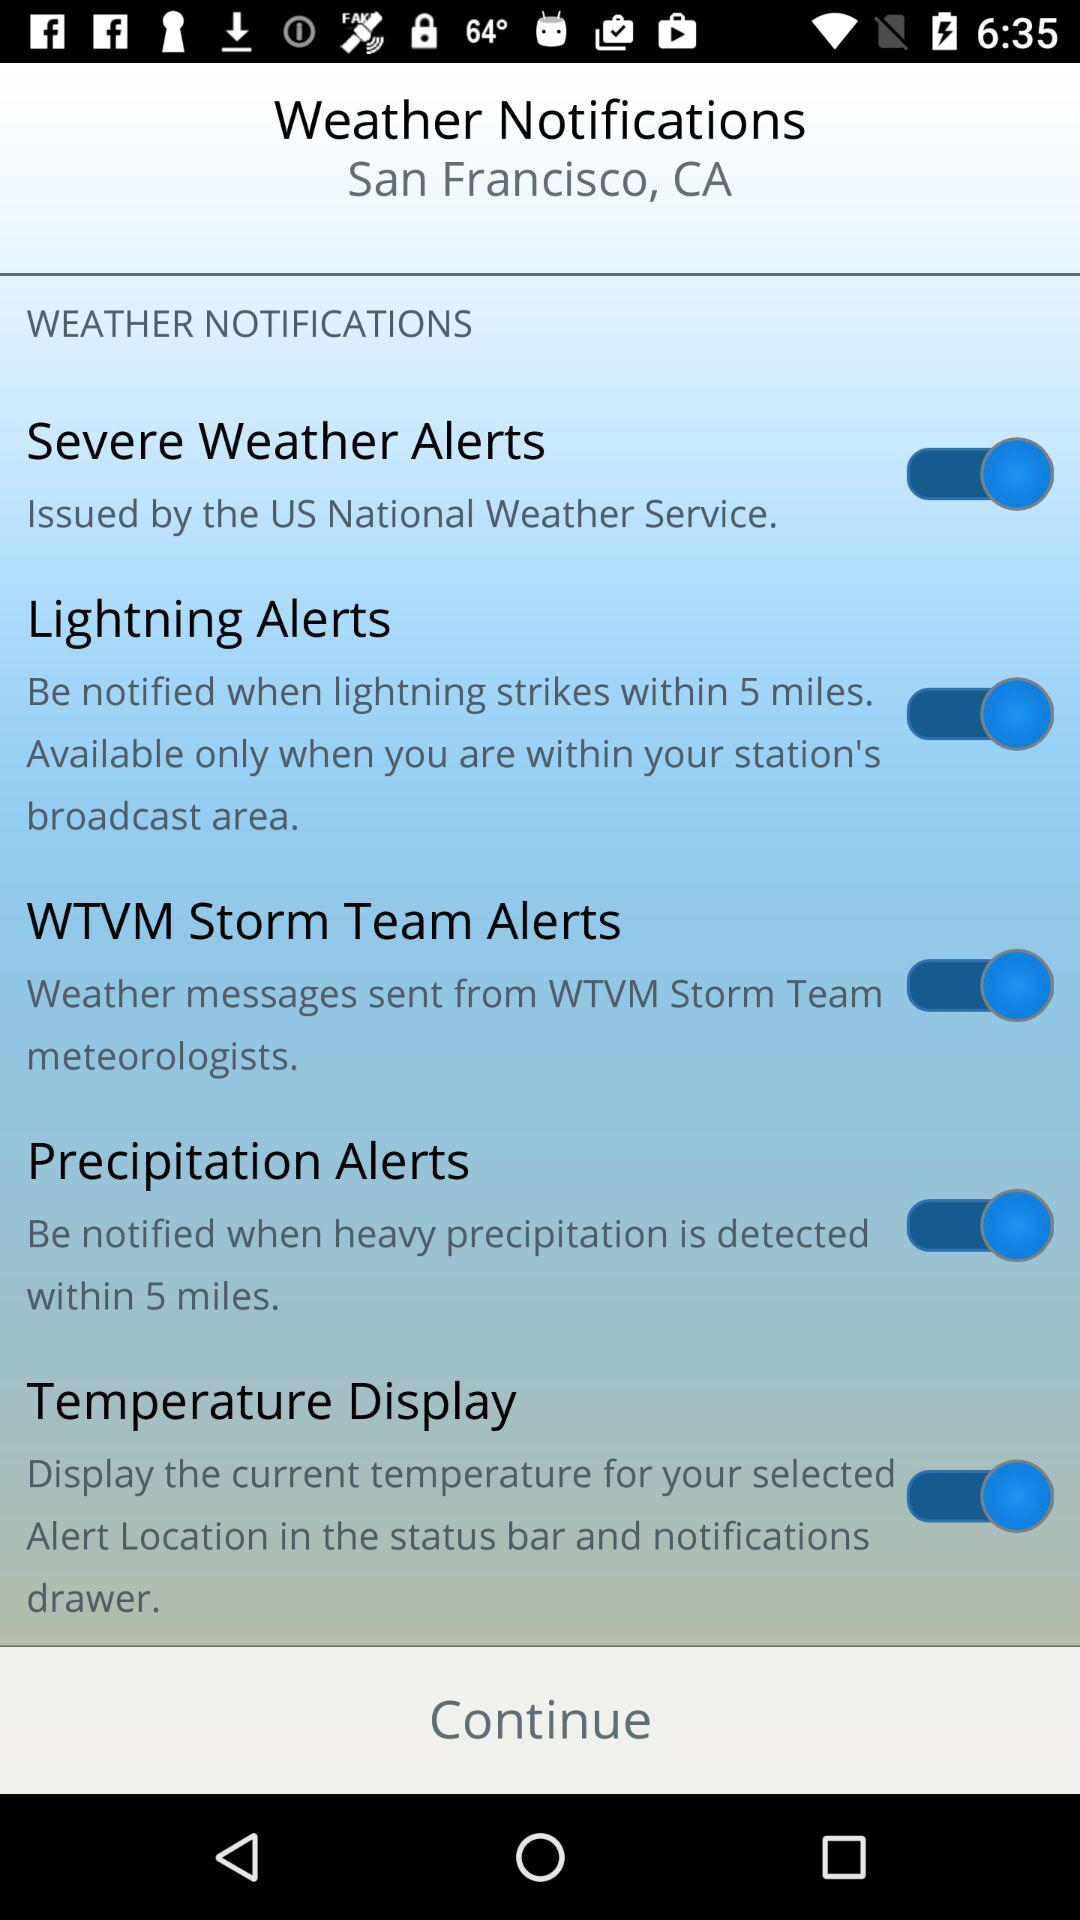Which options are "enabled" under the weather notifications? The "enabled" options are "Severe Weather Alerts", "Lightning Alerts", "WTVM Storm Team Alerts", "Precipitation Alerts" and "Temperature Display". 